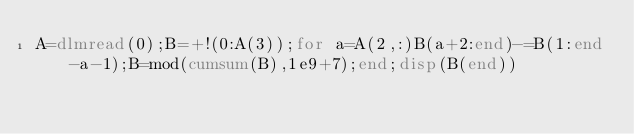Convert code to text. <code><loc_0><loc_0><loc_500><loc_500><_Octave_>A=dlmread(0);B=+!(0:A(3));for a=A(2,:)B(a+2:end)-=B(1:end-a-1);B=mod(cumsum(B),1e9+7);end;disp(B(end))</code> 